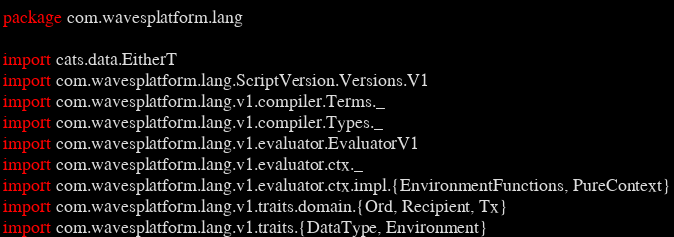Convert code to text. <code><loc_0><loc_0><loc_500><loc_500><_Scala_>package com.wavesplatform.lang

import cats.data.EitherT
import com.wavesplatform.lang.ScriptVersion.Versions.V1
import com.wavesplatform.lang.v1.compiler.Terms._
import com.wavesplatform.lang.v1.compiler.Types._
import com.wavesplatform.lang.v1.evaluator.EvaluatorV1
import com.wavesplatform.lang.v1.evaluator.ctx._
import com.wavesplatform.lang.v1.evaluator.ctx.impl.{EnvironmentFunctions, PureContext}
import com.wavesplatform.lang.v1.traits.domain.{Ord, Recipient, Tx}
import com.wavesplatform.lang.v1.traits.{DataType, Environment}</code> 